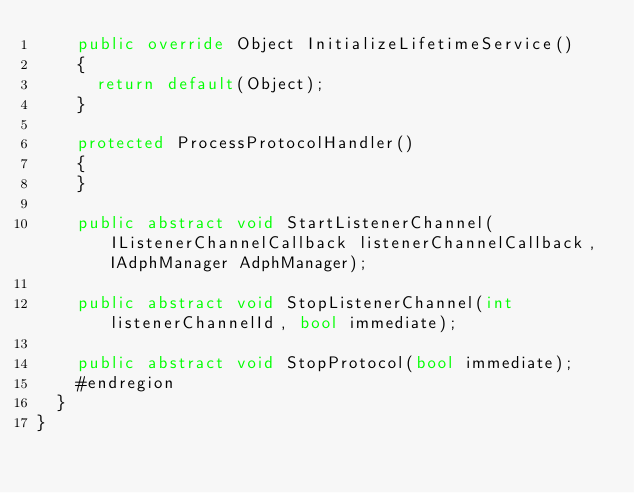<code> <loc_0><loc_0><loc_500><loc_500><_C#_>    public override Object InitializeLifetimeService()
    {
      return default(Object);
    }

    protected ProcessProtocolHandler()
    {
    }

    public abstract void StartListenerChannel(IListenerChannelCallback listenerChannelCallback, IAdphManager AdphManager);

    public abstract void StopListenerChannel(int listenerChannelId, bool immediate);

    public abstract void StopProtocol(bool immediate);
    #endregion
  }
}
</code> 